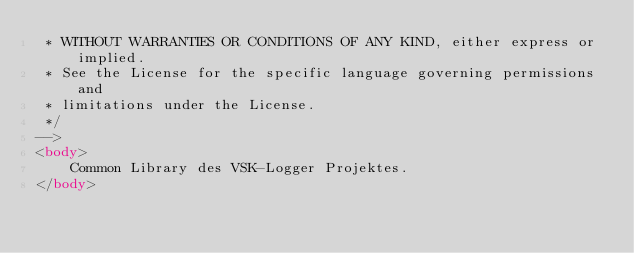Convert code to text. <code><loc_0><loc_0><loc_500><loc_500><_HTML_> * WITHOUT WARRANTIES OR CONDITIONS OF ANY KIND, either express or implied.
 * See the License for the specific language governing permissions and
 * limitations under the License.
 */
-->
<body>
    Common Library des VSK-Logger Projektes.
</body></code> 